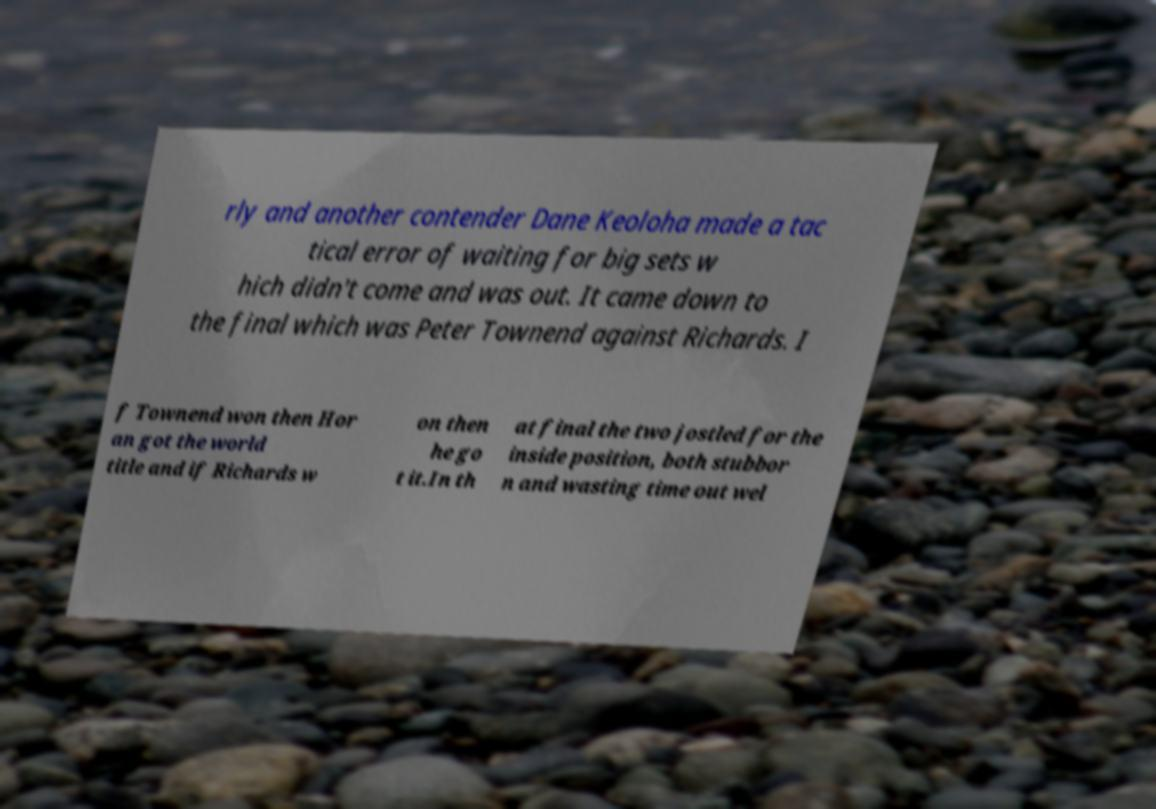For documentation purposes, I need the text within this image transcribed. Could you provide that? rly and another contender Dane Keoloha made a tac tical error of waiting for big sets w hich didn't come and was out. It came down to the final which was Peter Townend against Richards. I f Townend won then Hor an got the world title and if Richards w on then he go t it.In th at final the two jostled for the inside position, both stubbor n and wasting time out wel 